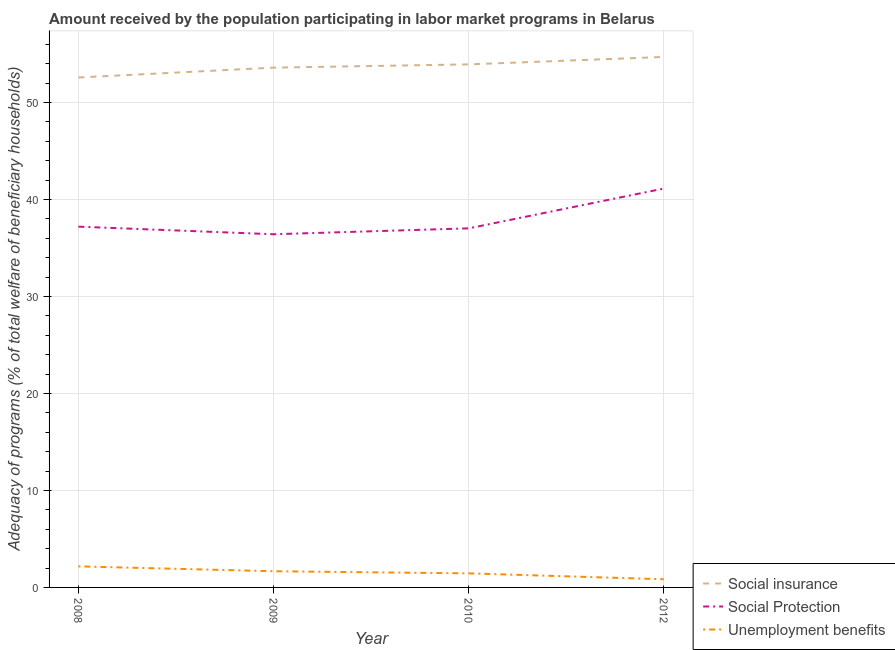What is the amount received by the population participating in social insurance programs in 2012?
Ensure brevity in your answer.  54.7. Across all years, what is the maximum amount received by the population participating in social protection programs?
Your answer should be very brief. 41.13. Across all years, what is the minimum amount received by the population participating in social insurance programs?
Keep it short and to the point. 52.58. What is the total amount received by the population participating in social protection programs in the graph?
Provide a succinct answer. 151.77. What is the difference between the amount received by the population participating in social protection programs in 2009 and that in 2012?
Provide a short and direct response. -4.71. What is the difference between the amount received by the population participating in unemployment benefits programs in 2010 and the amount received by the population participating in social protection programs in 2012?
Offer a very short reply. -39.68. What is the average amount received by the population participating in social protection programs per year?
Keep it short and to the point. 37.94. In the year 2008, what is the difference between the amount received by the population participating in social protection programs and amount received by the population participating in unemployment benefits programs?
Your answer should be very brief. 35.03. In how many years, is the amount received by the population participating in social insurance programs greater than 36 %?
Provide a succinct answer. 4. What is the ratio of the amount received by the population participating in unemployment benefits programs in 2010 to that in 2012?
Your answer should be compact. 1.72. What is the difference between the highest and the second highest amount received by the population participating in social insurance programs?
Your response must be concise. 0.77. What is the difference between the highest and the lowest amount received by the population participating in social insurance programs?
Give a very brief answer. 2.12. Is it the case that in every year, the sum of the amount received by the population participating in social insurance programs and amount received by the population participating in social protection programs is greater than the amount received by the population participating in unemployment benefits programs?
Give a very brief answer. Yes. Does the amount received by the population participating in unemployment benefits programs monotonically increase over the years?
Provide a succinct answer. No. Is the amount received by the population participating in social protection programs strictly less than the amount received by the population participating in social insurance programs over the years?
Offer a very short reply. Yes. What is the difference between two consecutive major ticks on the Y-axis?
Your answer should be very brief. 10. Are the values on the major ticks of Y-axis written in scientific E-notation?
Your response must be concise. No. Does the graph contain any zero values?
Make the answer very short. No. Where does the legend appear in the graph?
Your answer should be compact. Bottom right. How many legend labels are there?
Your answer should be compact. 3. How are the legend labels stacked?
Offer a terse response. Vertical. What is the title of the graph?
Ensure brevity in your answer.  Amount received by the population participating in labor market programs in Belarus. Does "Agriculture" appear as one of the legend labels in the graph?
Provide a short and direct response. No. What is the label or title of the X-axis?
Offer a terse response. Year. What is the label or title of the Y-axis?
Ensure brevity in your answer.  Adequacy of programs (% of total welfare of beneficiary households). What is the Adequacy of programs (% of total welfare of beneficiary households) in Social insurance in 2008?
Your answer should be compact. 52.58. What is the Adequacy of programs (% of total welfare of beneficiary households) of Social Protection in 2008?
Your answer should be very brief. 37.2. What is the Adequacy of programs (% of total welfare of beneficiary households) in Unemployment benefits in 2008?
Provide a succinct answer. 2.17. What is the Adequacy of programs (% of total welfare of beneficiary households) of Social insurance in 2009?
Offer a terse response. 53.6. What is the Adequacy of programs (% of total welfare of beneficiary households) in Social Protection in 2009?
Offer a terse response. 36.42. What is the Adequacy of programs (% of total welfare of beneficiary households) in Unemployment benefits in 2009?
Provide a succinct answer. 1.67. What is the Adequacy of programs (% of total welfare of beneficiary households) of Social insurance in 2010?
Your answer should be very brief. 53.93. What is the Adequacy of programs (% of total welfare of beneficiary households) of Social Protection in 2010?
Offer a terse response. 37.03. What is the Adequacy of programs (% of total welfare of beneficiary households) in Unemployment benefits in 2010?
Provide a succinct answer. 1.45. What is the Adequacy of programs (% of total welfare of beneficiary households) in Social insurance in 2012?
Provide a succinct answer. 54.7. What is the Adequacy of programs (% of total welfare of beneficiary households) of Social Protection in 2012?
Offer a very short reply. 41.13. What is the Adequacy of programs (% of total welfare of beneficiary households) of Unemployment benefits in 2012?
Keep it short and to the point. 0.84. Across all years, what is the maximum Adequacy of programs (% of total welfare of beneficiary households) of Social insurance?
Make the answer very short. 54.7. Across all years, what is the maximum Adequacy of programs (% of total welfare of beneficiary households) in Social Protection?
Your answer should be compact. 41.13. Across all years, what is the maximum Adequacy of programs (% of total welfare of beneficiary households) of Unemployment benefits?
Keep it short and to the point. 2.17. Across all years, what is the minimum Adequacy of programs (% of total welfare of beneficiary households) of Social insurance?
Provide a short and direct response. 52.58. Across all years, what is the minimum Adequacy of programs (% of total welfare of beneficiary households) in Social Protection?
Offer a terse response. 36.42. Across all years, what is the minimum Adequacy of programs (% of total welfare of beneficiary households) in Unemployment benefits?
Your answer should be compact. 0.84. What is the total Adequacy of programs (% of total welfare of beneficiary households) in Social insurance in the graph?
Your answer should be very brief. 214.81. What is the total Adequacy of programs (% of total welfare of beneficiary households) of Social Protection in the graph?
Give a very brief answer. 151.77. What is the total Adequacy of programs (% of total welfare of beneficiary households) in Unemployment benefits in the graph?
Your answer should be compact. 6.13. What is the difference between the Adequacy of programs (% of total welfare of beneficiary households) of Social insurance in 2008 and that in 2009?
Your answer should be very brief. -1.02. What is the difference between the Adequacy of programs (% of total welfare of beneficiary households) of Social Protection in 2008 and that in 2009?
Offer a very short reply. 0.78. What is the difference between the Adequacy of programs (% of total welfare of beneficiary households) of Unemployment benefits in 2008 and that in 2009?
Ensure brevity in your answer.  0.5. What is the difference between the Adequacy of programs (% of total welfare of beneficiary households) of Social insurance in 2008 and that in 2010?
Offer a terse response. -1.35. What is the difference between the Adequacy of programs (% of total welfare of beneficiary households) of Social Protection in 2008 and that in 2010?
Provide a succinct answer. 0.18. What is the difference between the Adequacy of programs (% of total welfare of beneficiary households) of Unemployment benefits in 2008 and that in 2010?
Provide a short and direct response. 0.72. What is the difference between the Adequacy of programs (% of total welfare of beneficiary households) of Social insurance in 2008 and that in 2012?
Ensure brevity in your answer.  -2.12. What is the difference between the Adequacy of programs (% of total welfare of beneficiary households) of Social Protection in 2008 and that in 2012?
Ensure brevity in your answer.  -3.93. What is the difference between the Adequacy of programs (% of total welfare of beneficiary households) of Unemployment benefits in 2008 and that in 2012?
Provide a succinct answer. 1.33. What is the difference between the Adequacy of programs (% of total welfare of beneficiary households) in Social insurance in 2009 and that in 2010?
Your response must be concise. -0.34. What is the difference between the Adequacy of programs (% of total welfare of beneficiary households) in Social Protection in 2009 and that in 2010?
Provide a short and direct response. -0.61. What is the difference between the Adequacy of programs (% of total welfare of beneficiary households) of Unemployment benefits in 2009 and that in 2010?
Offer a terse response. 0.22. What is the difference between the Adequacy of programs (% of total welfare of beneficiary households) in Social insurance in 2009 and that in 2012?
Offer a very short reply. -1.1. What is the difference between the Adequacy of programs (% of total welfare of beneficiary households) of Social Protection in 2009 and that in 2012?
Your response must be concise. -4.71. What is the difference between the Adequacy of programs (% of total welfare of beneficiary households) in Unemployment benefits in 2009 and that in 2012?
Your answer should be compact. 0.83. What is the difference between the Adequacy of programs (% of total welfare of beneficiary households) in Social insurance in 2010 and that in 2012?
Your answer should be compact. -0.77. What is the difference between the Adequacy of programs (% of total welfare of beneficiary households) of Social Protection in 2010 and that in 2012?
Your answer should be very brief. -4.1. What is the difference between the Adequacy of programs (% of total welfare of beneficiary households) of Unemployment benefits in 2010 and that in 2012?
Provide a succinct answer. 0.61. What is the difference between the Adequacy of programs (% of total welfare of beneficiary households) in Social insurance in 2008 and the Adequacy of programs (% of total welfare of beneficiary households) in Social Protection in 2009?
Provide a succinct answer. 16.16. What is the difference between the Adequacy of programs (% of total welfare of beneficiary households) in Social insurance in 2008 and the Adequacy of programs (% of total welfare of beneficiary households) in Unemployment benefits in 2009?
Provide a succinct answer. 50.91. What is the difference between the Adequacy of programs (% of total welfare of beneficiary households) of Social Protection in 2008 and the Adequacy of programs (% of total welfare of beneficiary households) of Unemployment benefits in 2009?
Give a very brief answer. 35.53. What is the difference between the Adequacy of programs (% of total welfare of beneficiary households) of Social insurance in 2008 and the Adequacy of programs (% of total welfare of beneficiary households) of Social Protection in 2010?
Your answer should be very brief. 15.55. What is the difference between the Adequacy of programs (% of total welfare of beneficiary households) in Social insurance in 2008 and the Adequacy of programs (% of total welfare of beneficiary households) in Unemployment benefits in 2010?
Ensure brevity in your answer.  51.13. What is the difference between the Adequacy of programs (% of total welfare of beneficiary households) in Social Protection in 2008 and the Adequacy of programs (% of total welfare of beneficiary households) in Unemployment benefits in 2010?
Make the answer very short. 35.75. What is the difference between the Adequacy of programs (% of total welfare of beneficiary households) in Social insurance in 2008 and the Adequacy of programs (% of total welfare of beneficiary households) in Social Protection in 2012?
Ensure brevity in your answer.  11.45. What is the difference between the Adequacy of programs (% of total welfare of beneficiary households) in Social insurance in 2008 and the Adequacy of programs (% of total welfare of beneficiary households) in Unemployment benefits in 2012?
Provide a succinct answer. 51.74. What is the difference between the Adequacy of programs (% of total welfare of beneficiary households) of Social Protection in 2008 and the Adequacy of programs (% of total welfare of beneficiary households) of Unemployment benefits in 2012?
Give a very brief answer. 36.36. What is the difference between the Adequacy of programs (% of total welfare of beneficiary households) in Social insurance in 2009 and the Adequacy of programs (% of total welfare of beneficiary households) in Social Protection in 2010?
Keep it short and to the point. 16.57. What is the difference between the Adequacy of programs (% of total welfare of beneficiary households) in Social insurance in 2009 and the Adequacy of programs (% of total welfare of beneficiary households) in Unemployment benefits in 2010?
Your answer should be very brief. 52.15. What is the difference between the Adequacy of programs (% of total welfare of beneficiary households) of Social Protection in 2009 and the Adequacy of programs (% of total welfare of beneficiary households) of Unemployment benefits in 2010?
Offer a terse response. 34.97. What is the difference between the Adequacy of programs (% of total welfare of beneficiary households) in Social insurance in 2009 and the Adequacy of programs (% of total welfare of beneficiary households) in Social Protection in 2012?
Your answer should be very brief. 12.47. What is the difference between the Adequacy of programs (% of total welfare of beneficiary households) of Social insurance in 2009 and the Adequacy of programs (% of total welfare of beneficiary households) of Unemployment benefits in 2012?
Keep it short and to the point. 52.76. What is the difference between the Adequacy of programs (% of total welfare of beneficiary households) of Social Protection in 2009 and the Adequacy of programs (% of total welfare of beneficiary households) of Unemployment benefits in 2012?
Provide a short and direct response. 35.58. What is the difference between the Adequacy of programs (% of total welfare of beneficiary households) in Social insurance in 2010 and the Adequacy of programs (% of total welfare of beneficiary households) in Social Protection in 2012?
Your answer should be very brief. 12.8. What is the difference between the Adequacy of programs (% of total welfare of beneficiary households) of Social insurance in 2010 and the Adequacy of programs (% of total welfare of beneficiary households) of Unemployment benefits in 2012?
Offer a very short reply. 53.09. What is the difference between the Adequacy of programs (% of total welfare of beneficiary households) in Social Protection in 2010 and the Adequacy of programs (% of total welfare of beneficiary households) in Unemployment benefits in 2012?
Ensure brevity in your answer.  36.18. What is the average Adequacy of programs (% of total welfare of beneficiary households) of Social insurance per year?
Keep it short and to the point. 53.7. What is the average Adequacy of programs (% of total welfare of beneficiary households) of Social Protection per year?
Give a very brief answer. 37.94. What is the average Adequacy of programs (% of total welfare of beneficiary households) in Unemployment benefits per year?
Keep it short and to the point. 1.53. In the year 2008, what is the difference between the Adequacy of programs (% of total welfare of beneficiary households) in Social insurance and Adequacy of programs (% of total welfare of beneficiary households) in Social Protection?
Offer a terse response. 15.38. In the year 2008, what is the difference between the Adequacy of programs (% of total welfare of beneficiary households) of Social insurance and Adequacy of programs (% of total welfare of beneficiary households) of Unemployment benefits?
Give a very brief answer. 50.41. In the year 2008, what is the difference between the Adequacy of programs (% of total welfare of beneficiary households) in Social Protection and Adequacy of programs (% of total welfare of beneficiary households) in Unemployment benefits?
Provide a succinct answer. 35.03. In the year 2009, what is the difference between the Adequacy of programs (% of total welfare of beneficiary households) in Social insurance and Adequacy of programs (% of total welfare of beneficiary households) in Social Protection?
Provide a succinct answer. 17.18. In the year 2009, what is the difference between the Adequacy of programs (% of total welfare of beneficiary households) of Social insurance and Adequacy of programs (% of total welfare of beneficiary households) of Unemployment benefits?
Provide a succinct answer. 51.93. In the year 2009, what is the difference between the Adequacy of programs (% of total welfare of beneficiary households) of Social Protection and Adequacy of programs (% of total welfare of beneficiary households) of Unemployment benefits?
Provide a succinct answer. 34.75. In the year 2010, what is the difference between the Adequacy of programs (% of total welfare of beneficiary households) of Social insurance and Adequacy of programs (% of total welfare of beneficiary households) of Social Protection?
Make the answer very short. 16.91. In the year 2010, what is the difference between the Adequacy of programs (% of total welfare of beneficiary households) in Social insurance and Adequacy of programs (% of total welfare of beneficiary households) in Unemployment benefits?
Offer a very short reply. 52.48. In the year 2010, what is the difference between the Adequacy of programs (% of total welfare of beneficiary households) in Social Protection and Adequacy of programs (% of total welfare of beneficiary households) in Unemployment benefits?
Give a very brief answer. 35.58. In the year 2012, what is the difference between the Adequacy of programs (% of total welfare of beneficiary households) in Social insurance and Adequacy of programs (% of total welfare of beneficiary households) in Social Protection?
Your answer should be very brief. 13.57. In the year 2012, what is the difference between the Adequacy of programs (% of total welfare of beneficiary households) of Social insurance and Adequacy of programs (% of total welfare of beneficiary households) of Unemployment benefits?
Offer a terse response. 53.86. In the year 2012, what is the difference between the Adequacy of programs (% of total welfare of beneficiary households) in Social Protection and Adequacy of programs (% of total welfare of beneficiary households) in Unemployment benefits?
Your response must be concise. 40.29. What is the ratio of the Adequacy of programs (% of total welfare of beneficiary households) in Social insurance in 2008 to that in 2009?
Your answer should be compact. 0.98. What is the ratio of the Adequacy of programs (% of total welfare of beneficiary households) of Social Protection in 2008 to that in 2009?
Offer a terse response. 1.02. What is the ratio of the Adequacy of programs (% of total welfare of beneficiary households) in Unemployment benefits in 2008 to that in 2009?
Your response must be concise. 1.3. What is the ratio of the Adequacy of programs (% of total welfare of beneficiary households) in Social insurance in 2008 to that in 2010?
Provide a short and direct response. 0.97. What is the ratio of the Adequacy of programs (% of total welfare of beneficiary households) in Social Protection in 2008 to that in 2010?
Offer a very short reply. 1. What is the ratio of the Adequacy of programs (% of total welfare of beneficiary households) of Unemployment benefits in 2008 to that in 2010?
Your answer should be compact. 1.5. What is the ratio of the Adequacy of programs (% of total welfare of beneficiary households) of Social insurance in 2008 to that in 2012?
Offer a terse response. 0.96. What is the ratio of the Adequacy of programs (% of total welfare of beneficiary households) in Social Protection in 2008 to that in 2012?
Provide a succinct answer. 0.9. What is the ratio of the Adequacy of programs (% of total welfare of beneficiary households) of Unemployment benefits in 2008 to that in 2012?
Your answer should be compact. 2.58. What is the ratio of the Adequacy of programs (% of total welfare of beneficiary households) in Social Protection in 2009 to that in 2010?
Your answer should be very brief. 0.98. What is the ratio of the Adequacy of programs (% of total welfare of beneficiary households) of Unemployment benefits in 2009 to that in 2010?
Provide a short and direct response. 1.15. What is the ratio of the Adequacy of programs (% of total welfare of beneficiary households) in Social insurance in 2009 to that in 2012?
Your answer should be compact. 0.98. What is the ratio of the Adequacy of programs (% of total welfare of beneficiary households) of Social Protection in 2009 to that in 2012?
Make the answer very short. 0.89. What is the ratio of the Adequacy of programs (% of total welfare of beneficiary households) of Unemployment benefits in 2009 to that in 2012?
Make the answer very short. 1.98. What is the ratio of the Adequacy of programs (% of total welfare of beneficiary households) in Social insurance in 2010 to that in 2012?
Your answer should be very brief. 0.99. What is the ratio of the Adequacy of programs (% of total welfare of beneficiary households) in Social Protection in 2010 to that in 2012?
Make the answer very short. 0.9. What is the ratio of the Adequacy of programs (% of total welfare of beneficiary households) in Unemployment benefits in 2010 to that in 2012?
Offer a terse response. 1.72. What is the difference between the highest and the second highest Adequacy of programs (% of total welfare of beneficiary households) of Social insurance?
Provide a succinct answer. 0.77. What is the difference between the highest and the second highest Adequacy of programs (% of total welfare of beneficiary households) of Social Protection?
Ensure brevity in your answer.  3.93. What is the difference between the highest and the second highest Adequacy of programs (% of total welfare of beneficiary households) of Unemployment benefits?
Provide a succinct answer. 0.5. What is the difference between the highest and the lowest Adequacy of programs (% of total welfare of beneficiary households) in Social insurance?
Your response must be concise. 2.12. What is the difference between the highest and the lowest Adequacy of programs (% of total welfare of beneficiary households) of Social Protection?
Provide a succinct answer. 4.71. What is the difference between the highest and the lowest Adequacy of programs (% of total welfare of beneficiary households) in Unemployment benefits?
Keep it short and to the point. 1.33. 